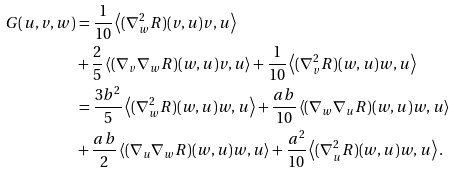<formula> <loc_0><loc_0><loc_500><loc_500>G ( u , v , w ) & = \frac { 1 } { 1 0 } \left < ( \nabla _ { w } ^ { 2 } R ) ( v , u ) v , u \right > \\ & + \frac { 2 } { 5 } \left < ( \nabla _ { v } \nabla _ { w } R ) ( w , u ) v , u \right > + \frac { 1 } { 1 0 } \left < ( \nabla _ { v } ^ { 2 } R ) ( w , u ) w , u \right > \\ & = \frac { 3 b ^ { 2 } } { 5 } \left < ( \nabla _ { w } ^ { 2 } R ) ( w , u ) w , u \right > + \frac { a b } { 1 0 } \left < ( \nabla _ { w } \nabla _ { u } R ) ( w , u ) w , u \right > \\ & + \frac { a b } { 2 } \left < ( \nabla _ { u } \nabla _ { w } R ) ( w , u ) w , u \right > + \frac { a ^ { 2 } } { 1 0 } \left < ( \nabla _ { u } ^ { 2 } R ) ( w , u ) w , u \right > .</formula> 